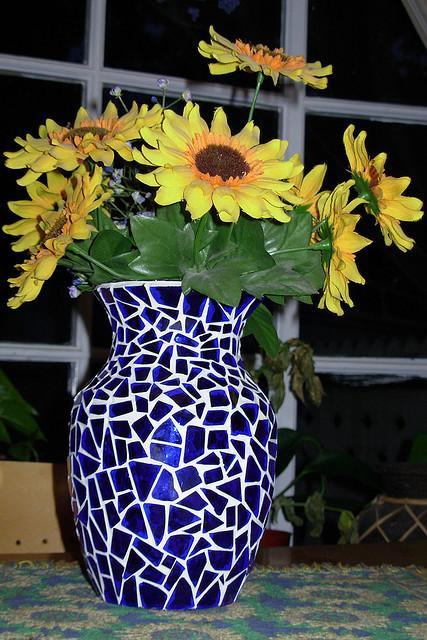Where is the vase likely placed?
Be succinct. On table. Are the flowers real?
Concise answer only. No. What is the vase made of?
Write a very short answer. Glass. 